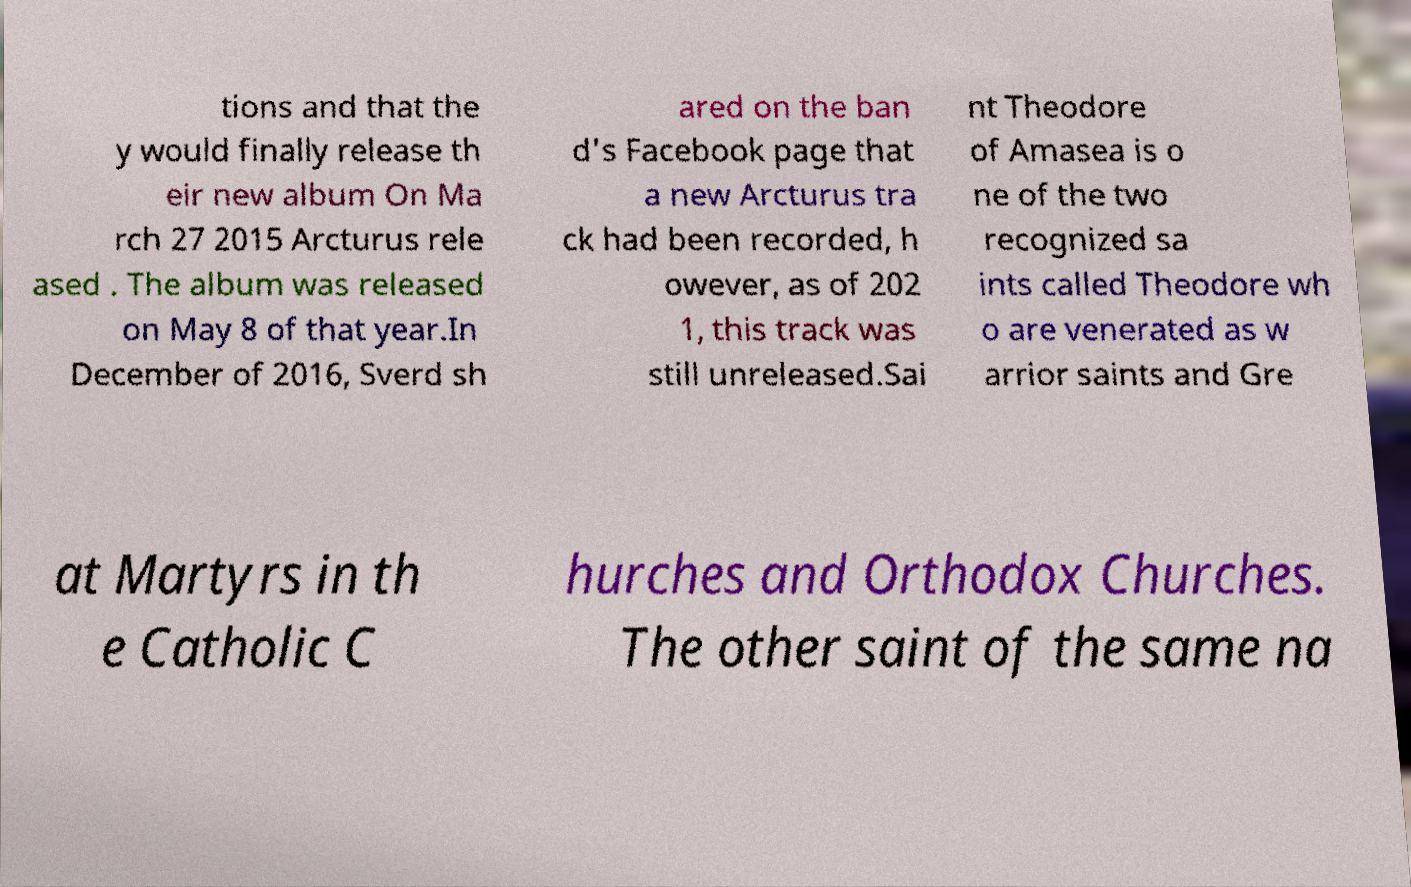Can you read and provide the text displayed in the image?This photo seems to have some interesting text. Can you extract and type it out for me? tions and that the y would finally release th eir new album On Ma rch 27 2015 Arcturus rele ased . The album was released on May 8 of that year.In December of 2016, Sverd sh ared on the ban d's Facebook page that a new Arcturus tra ck had been recorded, h owever, as of 202 1, this track was still unreleased.Sai nt Theodore of Amasea is o ne of the two recognized sa ints called Theodore wh o are venerated as w arrior saints and Gre at Martyrs in th e Catholic C hurches and Orthodox Churches. The other saint of the same na 